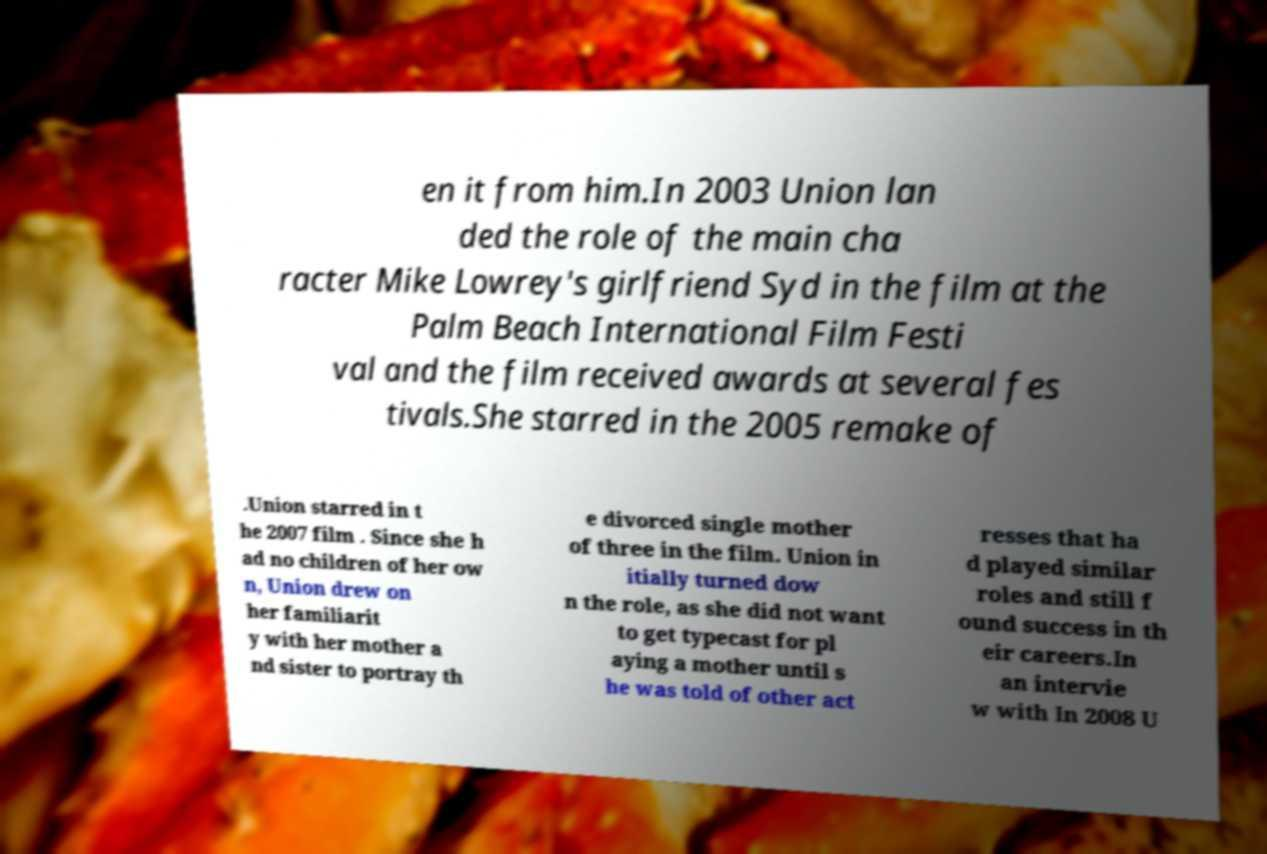What messages or text are displayed in this image? I need them in a readable, typed format. en it from him.In 2003 Union lan ded the role of the main cha racter Mike Lowrey's girlfriend Syd in the film at the Palm Beach International Film Festi val and the film received awards at several fes tivals.She starred in the 2005 remake of .Union starred in t he 2007 film . Since she h ad no children of her ow n, Union drew on her familiarit y with her mother a nd sister to portray th e divorced single mother of three in the film. Union in itially turned dow n the role, as she did not want to get typecast for pl aying a mother until s he was told of other act resses that ha d played similar roles and still f ound success in th eir careers.In an intervie w with In 2008 U 